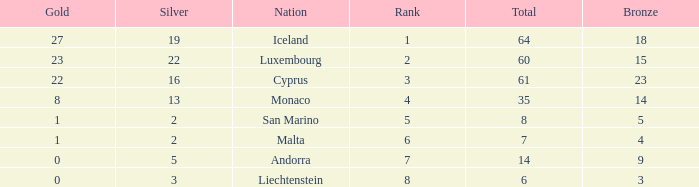How many bronzes for Iceland with over 2 silvers? 18.0. 